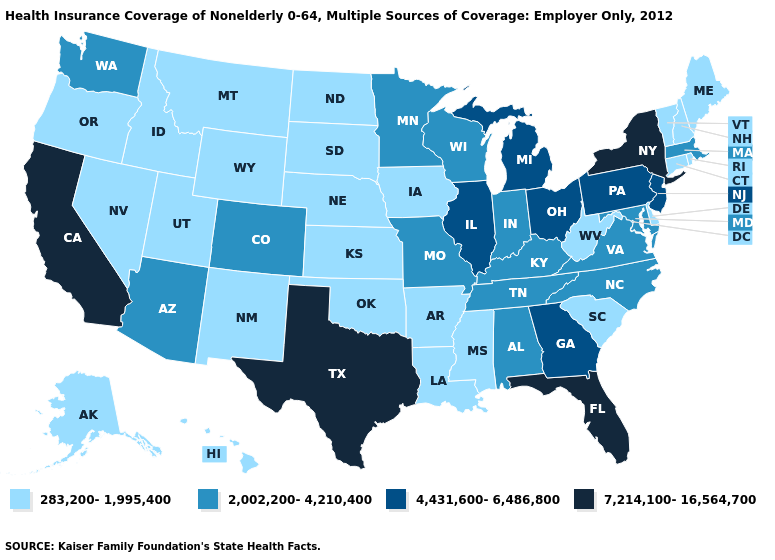Name the states that have a value in the range 283,200-1,995,400?
Concise answer only. Alaska, Arkansas, Connecticut, Delaware, Hawaii, Idaho, Iowa, Kansas, Louisiana, Maine, Mississippi, Montana, Nebraska, Nevada, New Hampshire, New Mexico, North Dakota, Oklahoma, Oregon, Rhode Island, South Carolina, South Dakota, Utah, Vermont, West Virginia, Wyoming. Name the states that have a value in the range 283,200-1,995,400?
Write a very short answer. Alaska, Arkansas, Connecticut, Delaware, Hawaii, Idaho, Iowa, Kansas, Louisiana, Maine, Mississippi, Montana, Nebraska, Nevada, New Hampshire, New Mexico, North Dakota, Oklahoma, Oregon, Rhode Island, South Carolina, South Dakota, Utah, Vermont, West Virginia, Wyoming. What is the value of California?
Be succinct. 7,214,100-16,564,700. Does California have the lowest value in the USA?
Quick response, please. No. Does New York have the highest value in the USA?
Quick response, please. Yes. Name the states that have a value in the range 7,214,100-16,564,700?
Be succinct. California, Florida, New York, Texas. What is the highest value in the USA?
Keep it brief. 7,214,100-16,564,700. Does the first symbol in the legend represent the smallest category?
Answer briefly. Yes. Is the legend a continuous bar?
Answer briefly. No. What is the value of North Dakota?
Short answer required. 283,200-1,995,400. What is the lowest value in the West?
Answer briefly. 283,200-1,995,400. Which states have the lowest value in the MidWest?
Answer briefly. Iowa, Kansas, Nebraska, North Dakota, South Dakota. How many symbols are there in the legend?
Give a very brief answer. 4. Among the states that border Illinois , does Indiana have the lowest value?
Answer briefly. No. How many symbols are there in the legend?
Quick response, please. 4. 